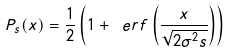Convert formula to latex. <formula><loc_0><loc_0><loc_500><loc_500>P _ { s } ( x ) = \frac { 1 } { 2 } \left ( 1 + \ e r f \left ( \frac { x } { \sqrt { 2 \sigma ^ { 2 } s } } \right ) \right )</formula> 